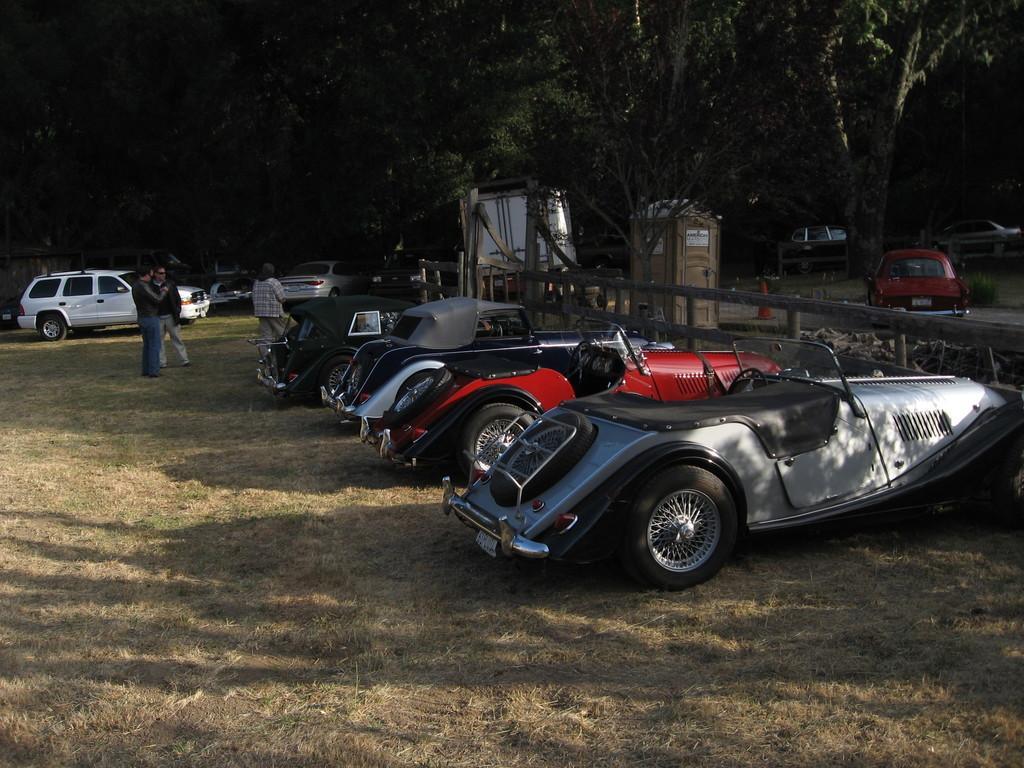How would you summarize this image in a sentence or two? In this image there are few vehicles parked and few persons standing on the surface of the grass, in front of them there is a railing and there is a wooden structure. In the background there are trees. 